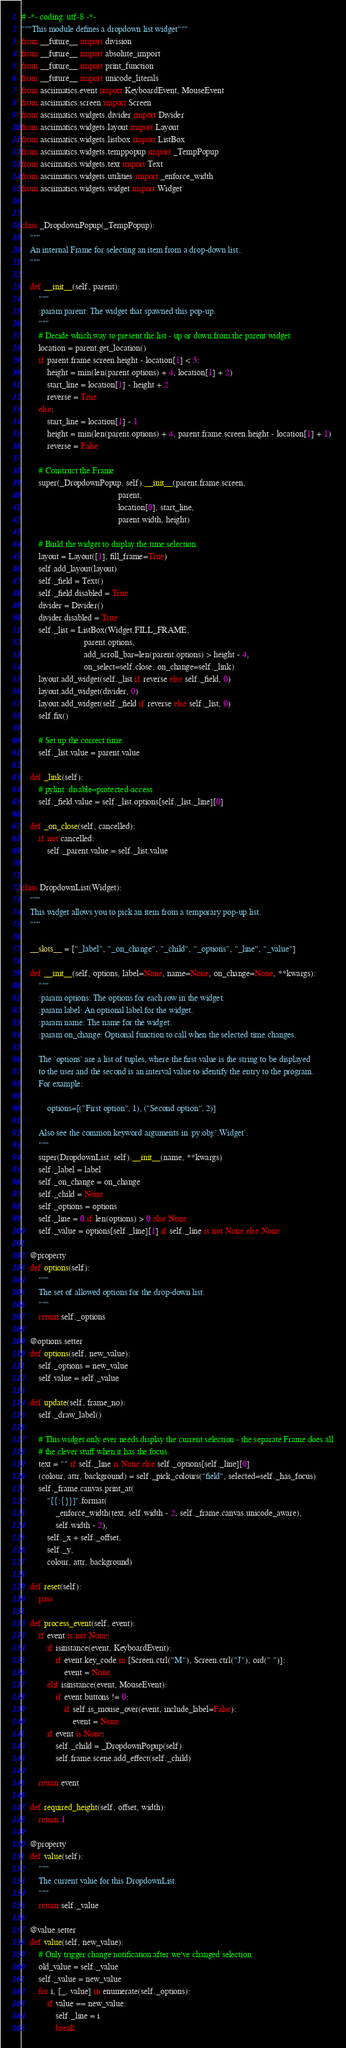<code> <loc_0><loc_0><loc_500><loc_500><_Python_># -*- coding: utf-8 -*-
"""This module defines a dropdown list widget"""
from __future__ import division
from __future__ import absolute_import
from __future__ import print_function
from __future__ import unicode_literals
from asciimatics.event import KeyboardEvent, MouseEvent
from asciimatics.screen import Screen
from asciimatics.widgets.divider import Divider
from asciimatics.widgets.layout import Layout
from asciimatics.widgets.listbox import ListBox
from asciimatics.widgets.temppopup import _TempPopup
from asciimatics.widgets.text import Text
from asciimatics.widgets.utilities import _enforce_width
from asciimatics.widgets.widget import Widget


class _DropdownPopup(_TempPopup):
    """
    An internal Frame for selecting an item from a drop-down list..
    """

    def __init__(self, parent):
        """
        :param parent: The widget that spawned this pop-up.
        """
        # Decide which way to present the list - up or down from the parent widget.
        location = parent.get_location()
        if parent.frame.screen.height - location[1] < 3:
            height = min(len(parent.options) + 4, location[1] + 2)
            start_line = location[1] - height + 2
            reverse = True
        else:
            start_line = location[1] - 1
            height = min(len(parent.options) + 4, parent.frame.screen.height - location[1] + 1)
            reverse = False

        # Construct the Frame
        super(_DropdownPopup, self).__init__(parent.frame.screen,
                                             parent,
                                             location[0], start_line,
                                             parent.width, height)

        # Build the widget to display the time selection.
        layout = Layout([1], fill_frame=True)
        self.add_layout(layout)
        self._field = Text()
        self._field.disabled = True
        divider = Divider()
        divider.disabled = True
        self._list = ListBox(Widget.FILL_FRAME,
                             parent.options,
                             add_scroll_bar=len(parent.options) > height - 4,
                             on_select=self.close, on_change=self._link)
        layout.add_widget(self._list if reverse else self._field, 0)
        layout.add_widget(divider, 0)
        layout.add_widget(self._field if reverse else self._list, 0)
        self.fix()

        # Set up the correct time.
        self._list.value = parent.value

    def _link(self):
        # pylint: disable=protected-access
        self._field.value = self._list.options[self._list._line][0]

    def _on_close(self, cancelled):
        if not cancelled:
            self._parent.value = self._list.value


class DropdownList(Widget):
    """
    This widget allows you to pick an item from a temporary pop-up list.
    """

    __slots__ = ["_label", "_on_change", "_child", "_options", "_line", "_value"]

    def __init__(self, options, label=None, name=None, on_change=None, **kwargs):
        """
        :param options: The options for each row in the widget.
        :param label: An optional label for the widget.
        :param name: The name for the widget.
        :param on_change: Optional function to call when the selected time changes.

        The `options` are a list of tuples, where the first value is the string to be displayed
        to the user and the second is an interval value to identify the entry to the program.
        For example:

            options=[("First option", 1), ("Second option", 2)]

        Also see the common keyword arguments in :py:obj:`.Widget`.
        """
        super(DropdownList, self).__init__(name, **kwargs)
        self._label = label
        self._on_change = on_change
        self._child = None
        self._options = options
        self._line = 0 if len(options) > 0 else None
        self._value = options[self._line][1] if self._line is not None else None

    @property
    def options(self):
        """
        The set of allowed options for the drop-down list.
        """
        return self._options

    @options.setter
    def options(self, new_value):
        self._options = new_value
        self.value = self._value

    def update(self, frame_no):
        self._draw_label()

        # This widget only ever needs display the current selection - the separate Frame does all
        # the clever stuff when it has the focus.
        text = "" if self._line is None else self._options[self._line][0]
        (colour, attr, background) = self._pick_colours("field", selected=self._has_focus)
        self._frame.canvas.print_at(
            "[{:{}}]".format(
                _enforce_width(text, self.width - 2, self._frame.canvas.unicode_aware),
                self.width - 2),
            self._x + self._offset,
            self._y,
            colour, attr, background)

    def reset(self):
        pass

    def process_event(self, event):
        if event is not None:
            if isinstance(event, KeyboardEvent):
                if event.key_code in [Screen.ctrl("M"), Screen.ctrl("J"), ord(" ")]:
                    event = None
            elif isinstance(event, MouseEvent):
                if event.buttons != 0:
                    if self.is_mouse_over(event, include_label=False):
                        event = None
            if event is None:
                self._child = _DropdownPopup(self)
                self.frame.scene.add_effect(self._child)

        return event

    def required_height(self, offset, width):
        return 1

    @property
    def value(self):
        """
        The current value for this DropdownList.
        """
        return self._value

    @value.setter
    def value(self, new_value):
        # Only trigger change notification after we've changed selection
        old_value = self._value
        self._value = new_value
        for i, [_, value] in enumerate(self._options):
            if value == new_value:
                self._line = i
                break</code> 